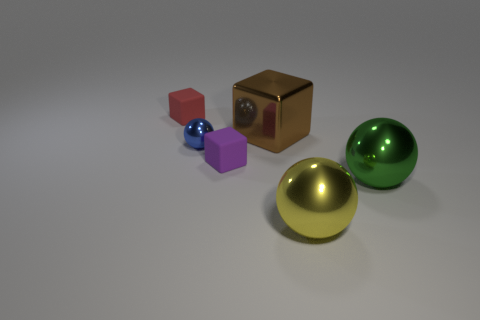What are the objects arranged on the surface, and what can you tell me about their colors and textures? In the image, there's a collection of geometric shapes arranged on a flat surface. From left to right, there's a small red cube, a smaller blue sphere, a magenta cube slightly larger than the first, a rich bronze cube, followed by a glossy yellow sphere, and finally a large green sphere. The objects showcase a variety of colors with matte, shiny, and metallic textures, offering a simple yet compelling study in geometry and reflections. 